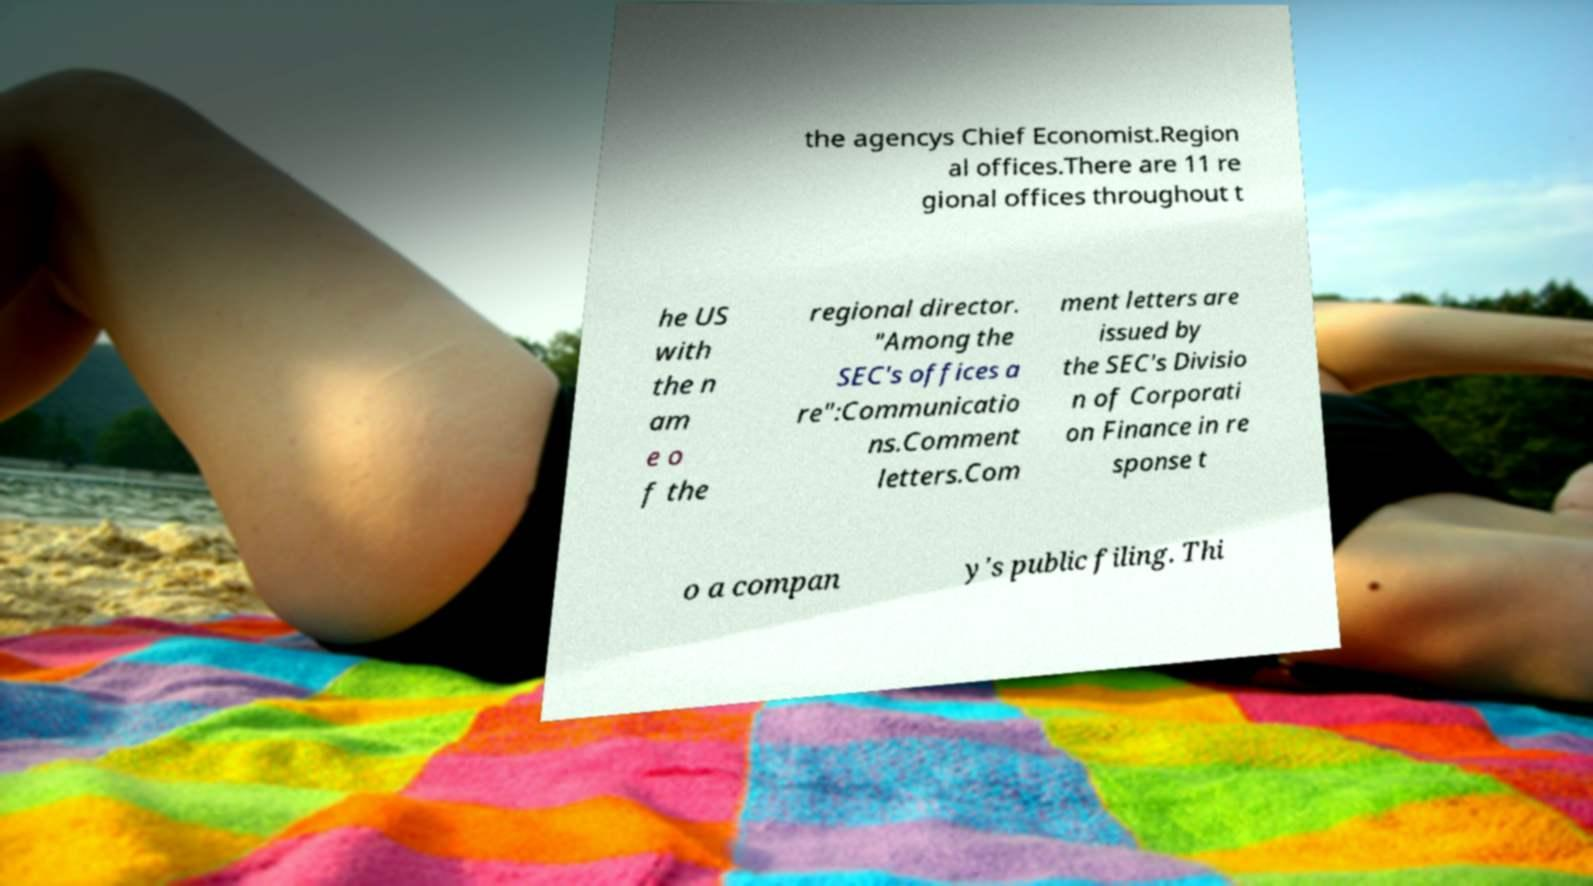Can you accurately transcribe the text from the provided image for me? the agencys Chief Economist.Region al offices.There are 11 re gional offices throughout t he US with the n am e o f the regional director. "Among the SEC's offices a re":Communicatio ns.Comment letters.Com ment letters are issued by the SEC's Divisio n of Corporati on Finance in re sponse t o a compan y's public filing. Thi 